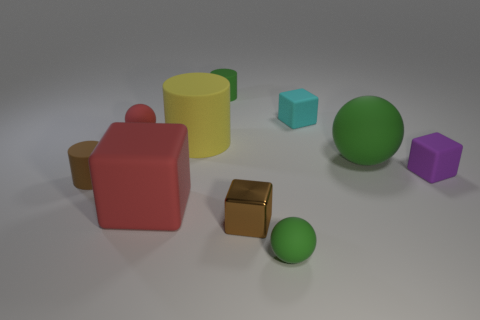There is a tiny rubber cylinder that is on the right side of the large yellow rubber cylinder; is it the same color as the large rubber sphere?
Keep it short and to the point. Yes. Is the material of the tiny brown cylinder the same as the brown cube?
Provide a succinct answer. No. There is a tiny block left of the tiny green ball; are there any tiny red objects that are behind it?
Make the answer very short. Yes. Does the tiny object to the left of the tiny red matte sphere have the same shape as the yellow matte thing?
Ensure brevity in your answer.  Yes. What is the shape of the tiny shiny thing?
Give a very brief answer. Cube. What number of brown cylinders are the same material as the big cube?
Offer a terse response. 1. There is a big rubber ball; does it have the same color as the small object in front of the metal block?
Ensure brevity in your answer.  Yes. What number of blue cubes are there?
Your answer should be compact. 0. Is there a small cylinder of the same color as the tiny metallic block?
Offer a terse response. Yes. There is a small ball in front of the big matte object that is to the right of the small sphere in front of the small red object; what color is it?
Make the answer very short. Green. 